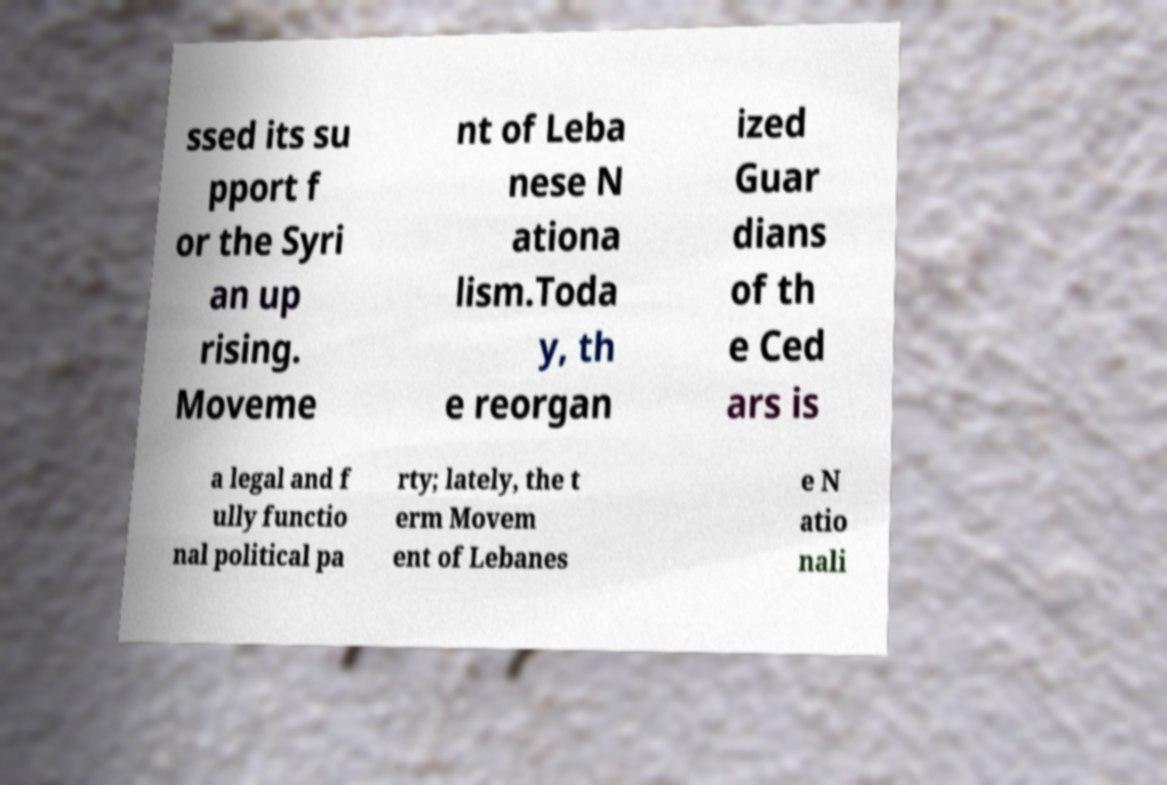Can you accurately transcribe the text from the provided image for me? ssed its su pport f or the Syri an up rising. Moveme nt of Leba nese N ationa lism.Toda y, th e reorgan ized Guar dians of th e Ced ars is a legal and f ully functio nal political pa rty; lately, the t erm Movem ent of Lebanes e N atio nali 